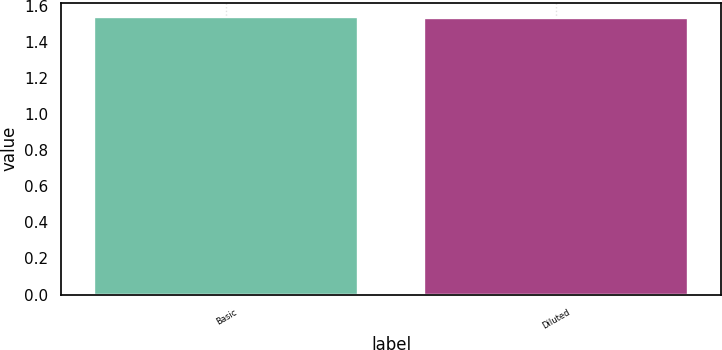<chart> <loc_0><loc_0><loc_500><loc_500><bar_chart><fcel>Basic<fcel>Diluted<nl><fcel>1.54<fcel>1.53<nl></chart> 